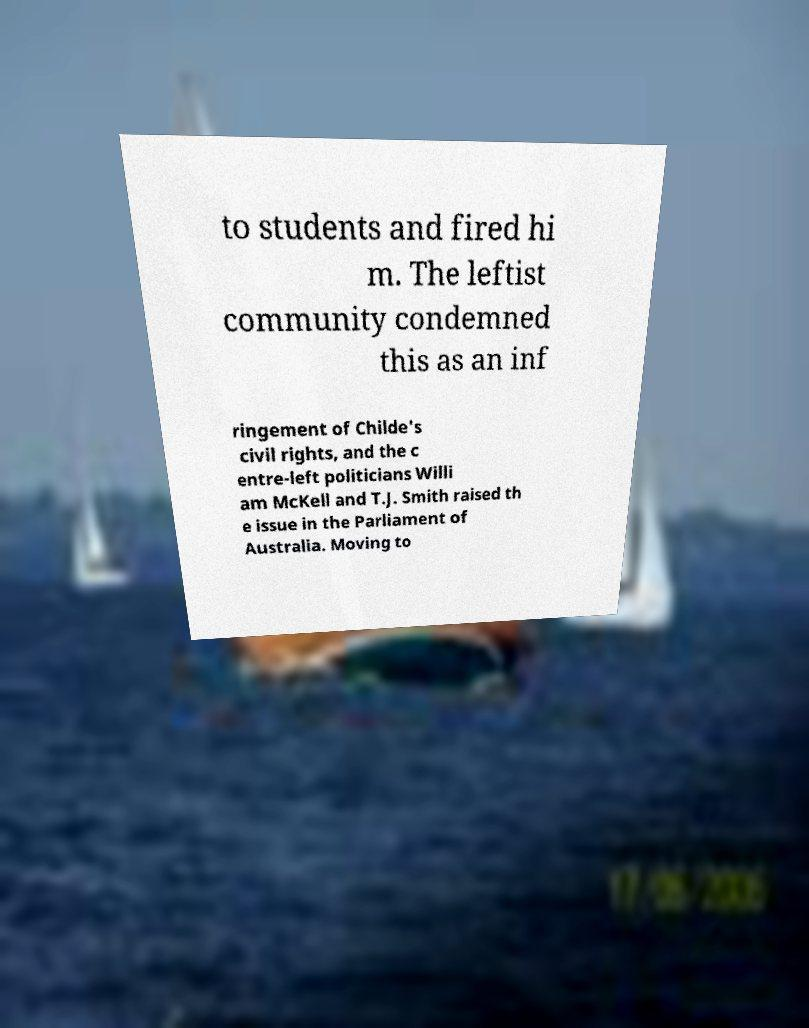Could you extract and type out the text from this image? to students and fired hi m. The leftist community condemned this as an inf ringement of Childe's civil rights, and the c entre-left politicians Willi am McKell and T.J. Smith raised th e issue in the Parliament of Australia. Moving to 